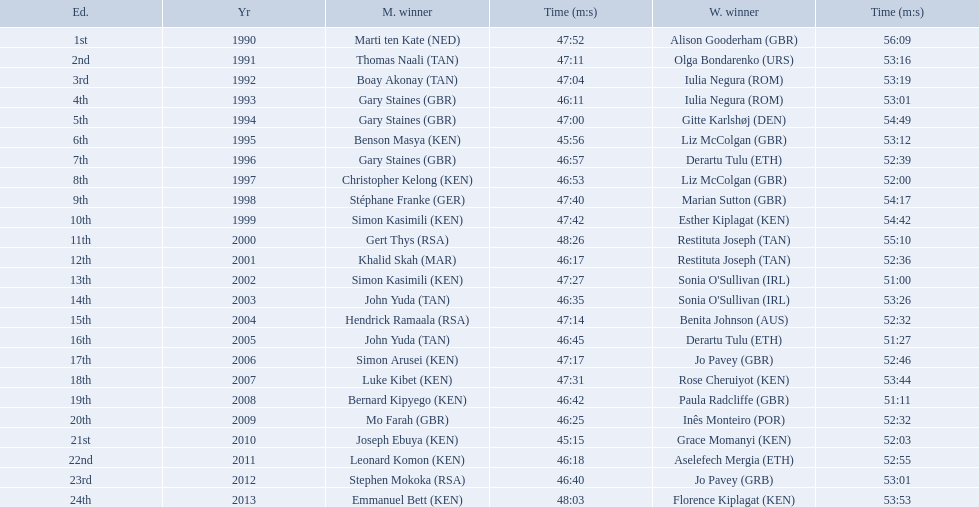What years were the races held? 1990, 1991, 1992, 1993, 1994, 1995, 1996, 1997, 1998, 1999, 2000, 2001, 2002, 2003, 2004, 2005, 2006, 2007, 2008, 2009, 2010, 2011, 2012, 2013. Who was the woman's winner of the 2003 race? Sonia O'Sullivan (IRL). What was her time? 53:26. Which of the runner in the great south run were women? Alison Gooderham (GBR), Olga Bondarenko (URS), Iulia Negura (ROM), Iulia Negura (ROM), Gitte Karlshøj (DEN), Liz McColgan (GBR), Derartu Tulu (ETH), Liz McColgan (GBR), Marian Sutton (GBR), Esther Kiplagat (KEN), Restituta Joseph (TAN), Restituta Joseph (TAN), Sonia O'Sullivan (IRL), Sonia O'Sullivan (IRL), Benita Johnson (AUS), Derartu Tulu (ETH), Jo Pavey (GBR), Rose Cheruiyot (KEN), Paula Radcliffe (GBR), Inês Monteiro (POR), Grace Momanyi (KEN), Aselefech Mergia (ETH), Jo Pavey (GRB), Florence Kiplagat (KEN). Of those women, which ones had a time of at least 53 minutes? Alison Gooderham (GBR), Olga Bondarenko (URS), Iulia Negura (ROM), Iulia Negura (ROM), Gitte Karlshøj (DEN), Liz McColgan (GBR), Marian Sutton (GBR), Esther Kiplagat (KEN), Restituta Joseph (TAN), Sonia O'Sullivan (IRL), Rose Cheruiyot (KEN), Jo Pavey (GRB), Florence Kiplagat (KEN). Between those women, which ones did not go over 53 minutes? Olga Bondarenko (URS), Iulia Negura (ROM), Iulia Negura (ROM), Liz McColgan (GBR), Sonia O'Sullivan (IRL), Rose Cheruiyot (KEN), Jo Pavey (GRB), Florence Kiplagat (KEN). Of those 8, what were the three slowest times? Sonia O'Sullivan (IRL), Rose Cheruiyot (KEN), Florence Kiplagat (KEN). Between only those 3 women, which runner had the fastest time? Sonia O'Sullivan (IRL). What was this women's time? 53:26. What place did sonia o'sullivan finish in 2003? 14th. How long did it take her to finish? 53:26. 